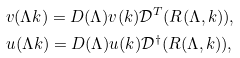Convert formula to latex. <formula><loc_0><loc_0><loc_500><loc_500>& v ( \Lambda k ) = D ( \Lambda ) v ( k ) \mathcal { D } ^ { T } ( R ( \Lambda , k ) ) , \\ & u ( \Lambda k ) = D ( \Lambda ) u ( k ) \mathcal { D } ^ { \dag } ( R ( \Lambda , k ) ) ,</formula> 